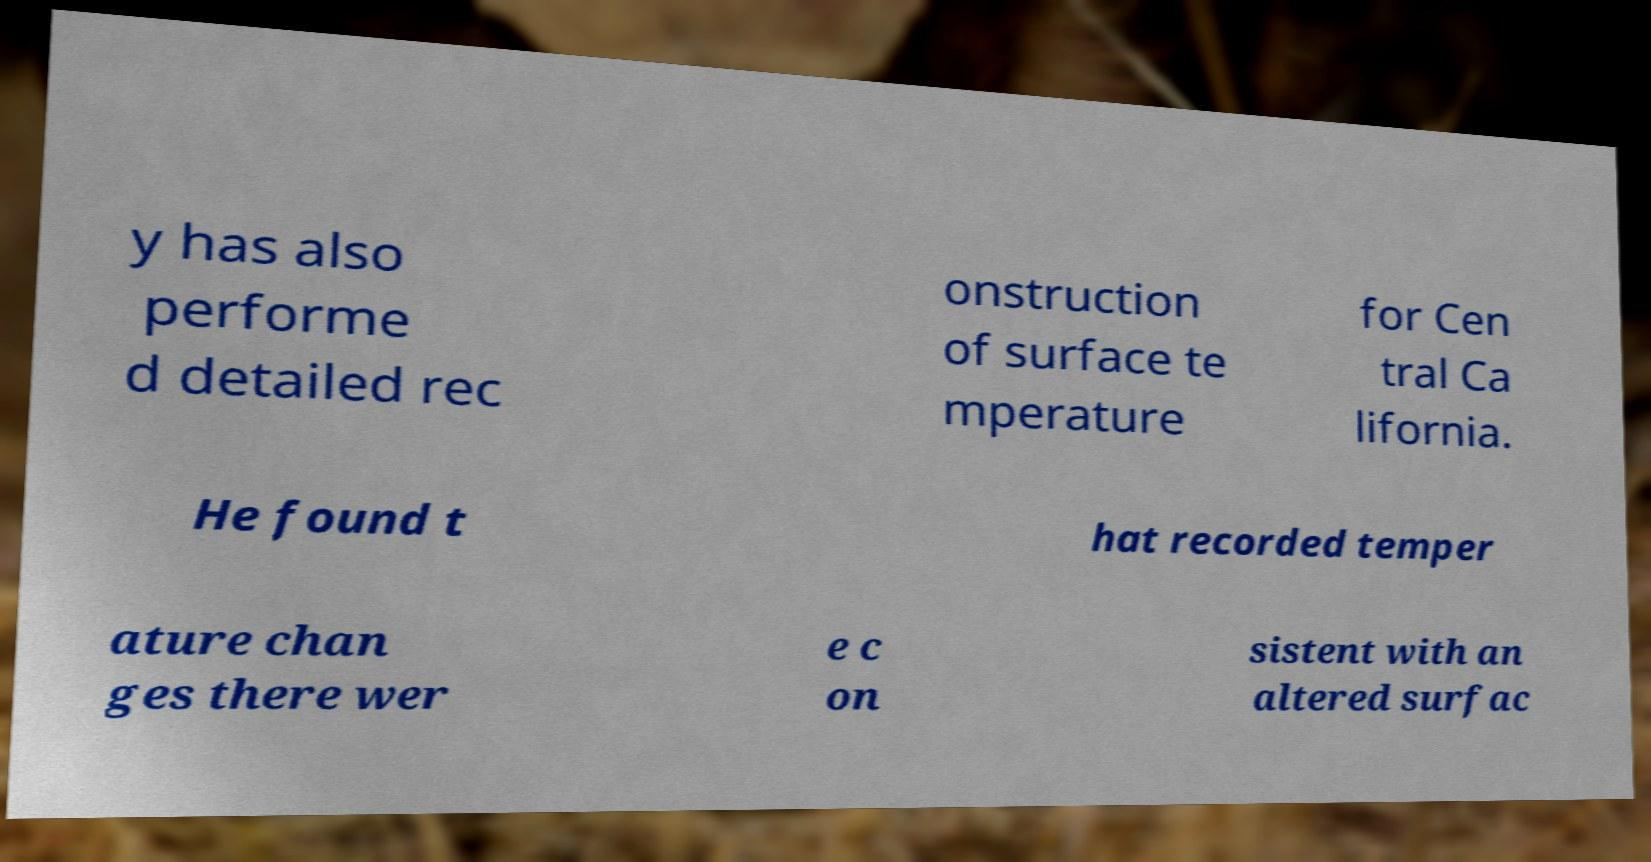Can you accurately transcribe the text from the provided image for me? y has also performe d detailed rec onstruction of surface te mperature for Cen tral Ca lifornia. He found t hat recorded temper ature chan ges there wer e c on sistent with an altered surfac 